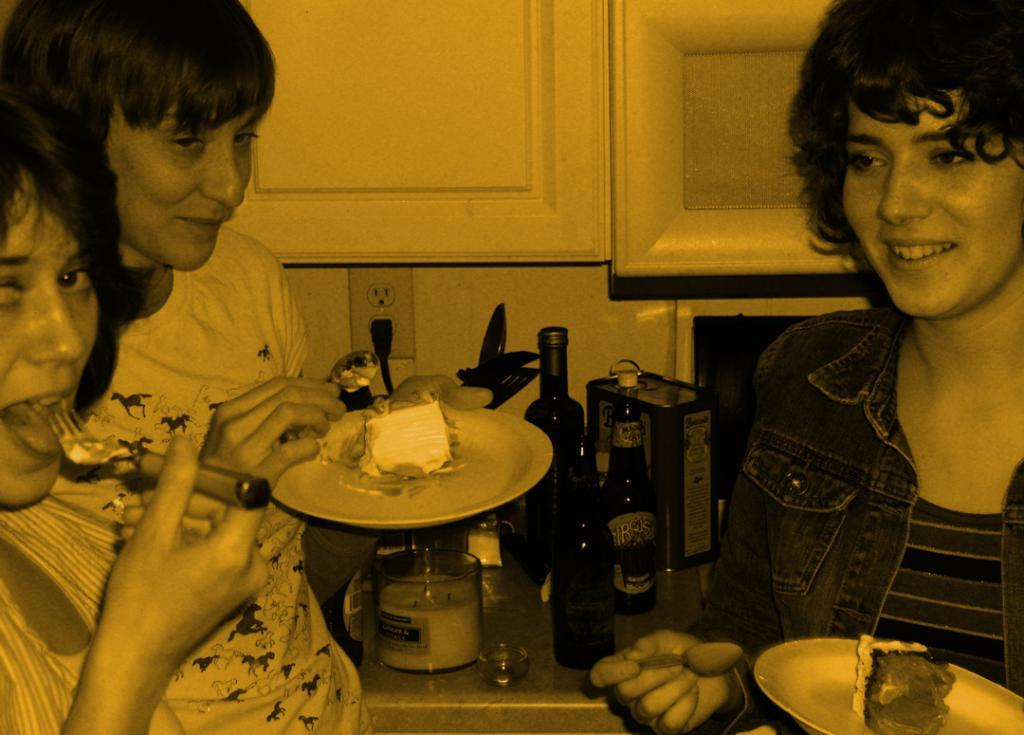How many people are in the image? There are three persons in the image. What are the persons holding in their hands? The persons are holding plates and spoons. One person is also holding a fork. What other objects can be seen in the image? There are bottles, a box, and a glass in the image. What type of quince can be seen in the image? There is no quince present in the image. Can you hear the persons laughing in the image? The image is silent, so we cannot hear any laughter. 